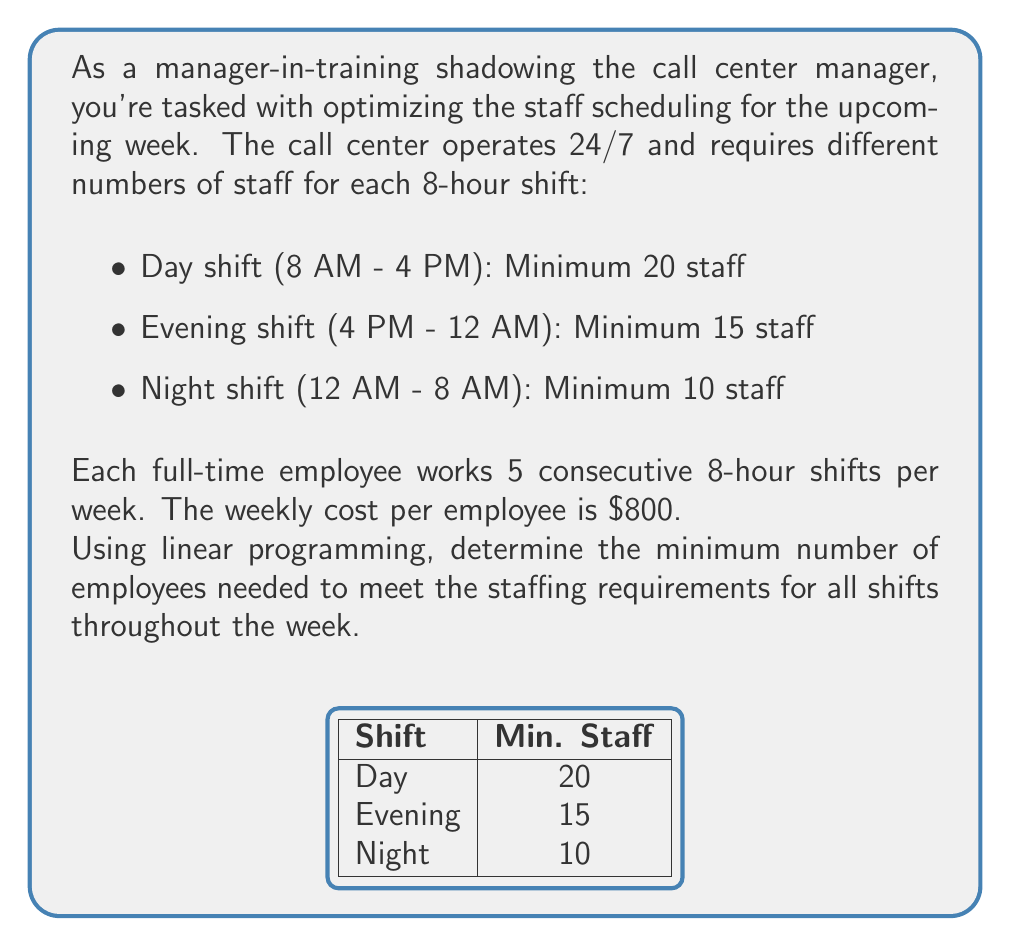Give your solution to this math problem. Let's approach this step-by-step using linear programming:

1) Define variables:
   Let $x$, $y$, and $z$ be the number of employees starting their 5-day shift on the day, evening, and night shifts respectively.

2) Objective function:
   We want to minimize the total number of employees:
   $$\text{Minimize } f(x,y,z) = x + y + z$$

3) Constraints:
   For each day of the week, we need to ensure that the minimum staffing requirements are met:

   Day shift: $x + y + z \geq 20$
   Evening shift: $x + y + z \geq 15$
   Night shift: $x + y + z \geq 10$

   Note that each employee works 5 consecutive shifts, so they contribute to all three shift types.

4) Non-negativity:
   $x \geq 0, y \geq 0, z \geq 0$

5) Solve:
   The binding constraint is the day shift, as it requires the most staff (20).
   Given that each employee works 5 days, we need:

   $$\frac{20 \text{ staff} \times 7 \text{ days}}{5 \text{ workdays per employee}} = 28 \text{ employees}$$

6) Verify:
   With 28 employees, we can schedule:
   - Day shift: 28 staff (exceeds 20)
   - Evening shift: 28 staff (exceeds 15)
   - Night shift: 28 staff (exceeds 10)

Therefore, 28 employees is the minimum number that satisfies all constraints.
Answer: 28 employees 